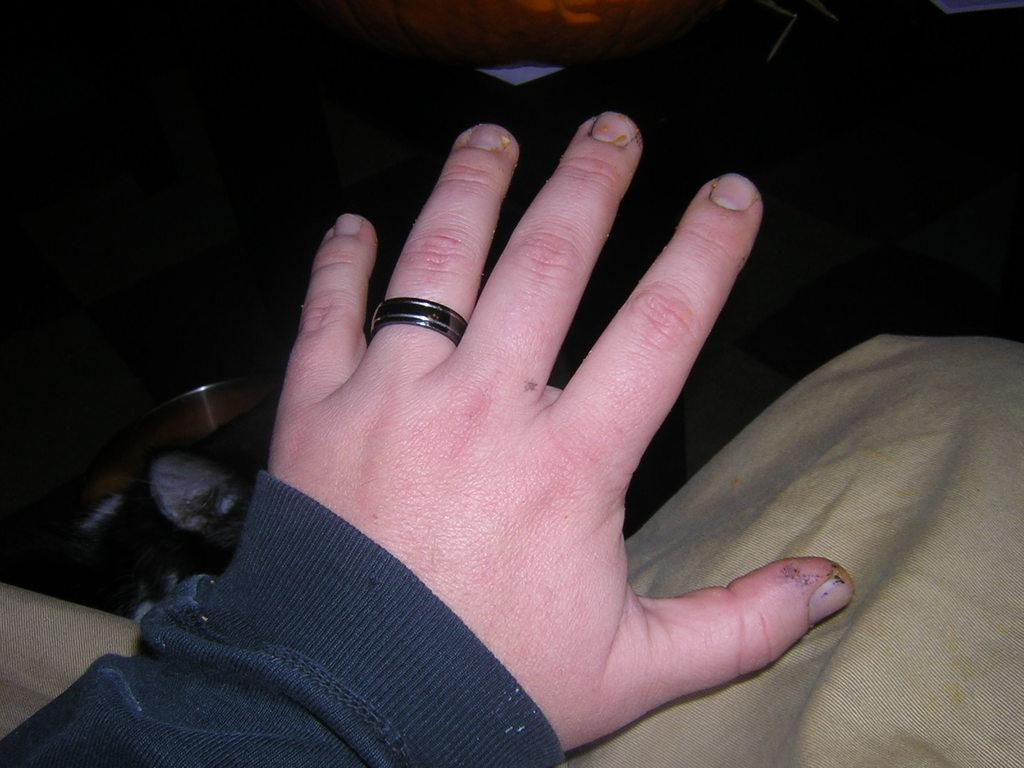What part of a person is visible in the image? There is a hand of a person in the image. What is on the finger of the hand? There is a ring on the finger of the hand. What type of bat can be seen flying in the image? There is no bat present in the image; it only features a hand with a ring on the finger. 